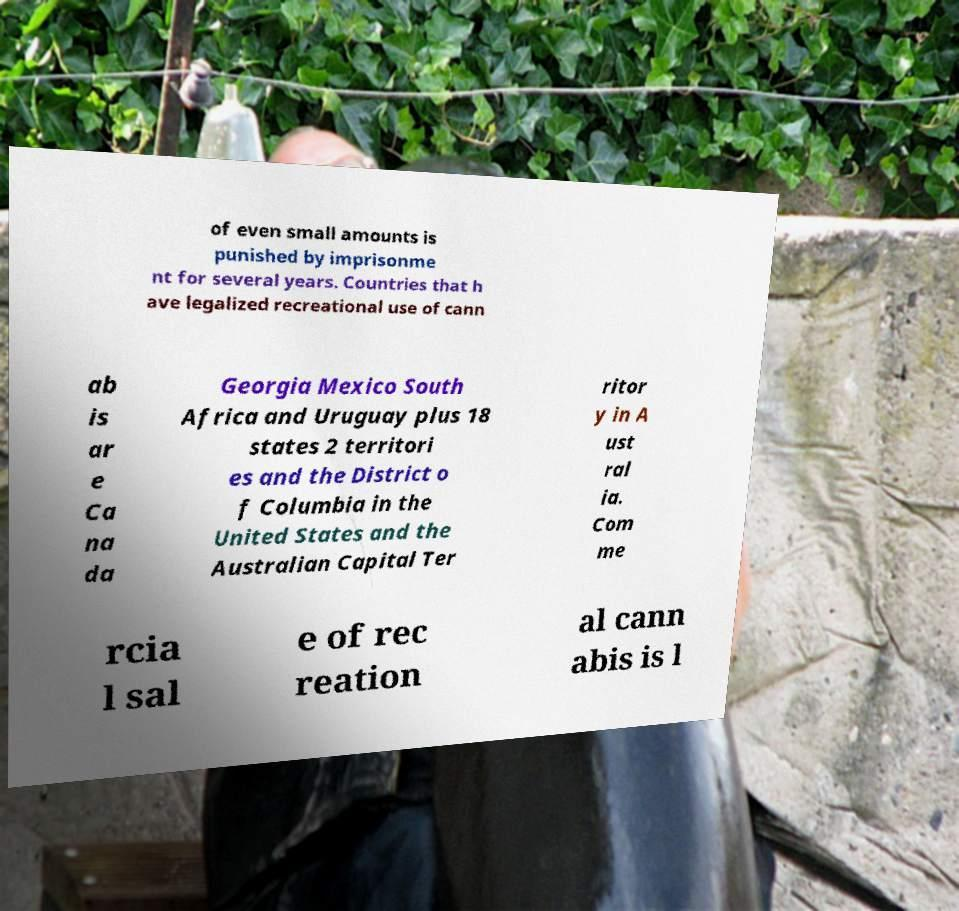I need the written content from this picture converted into text. Can you do that? of even small amounts is punished by imprisonme nt for several years. Countries that h ave legalized recreational use of cann ab is ar e Ca na da Georgia Mexico South Africa and Uruguay plus 18 states 2 territori es and the District o f Columbia in the United States and the Australian Capital Ter ritor y in A ust ral ia. Com me rcia l sal e of rec reation al cann abis is l 